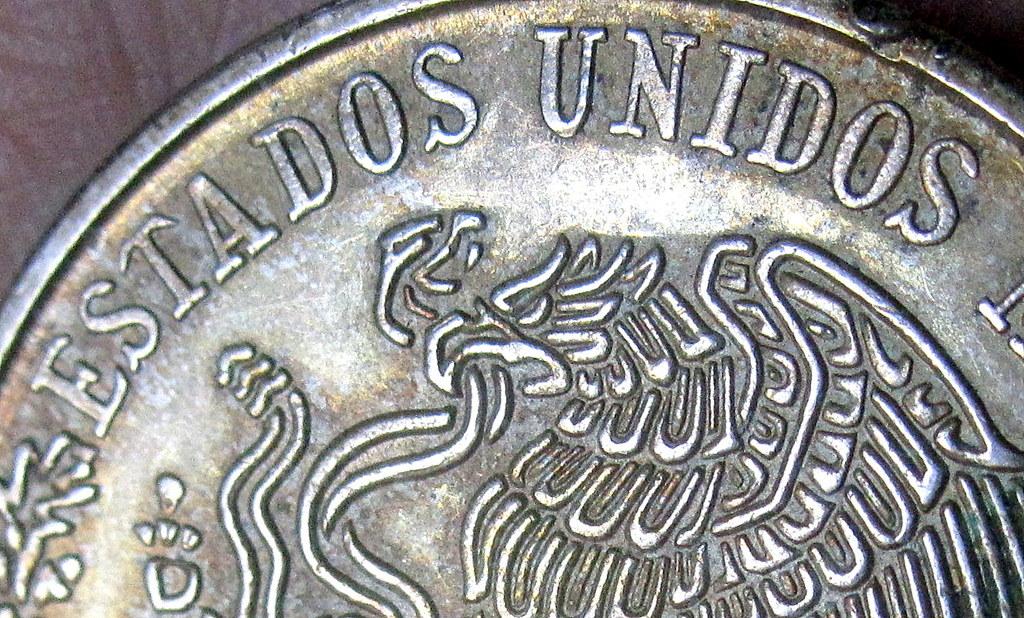What  country is this coin from?
Ensure brevity in your answer.  Unanswerable. 